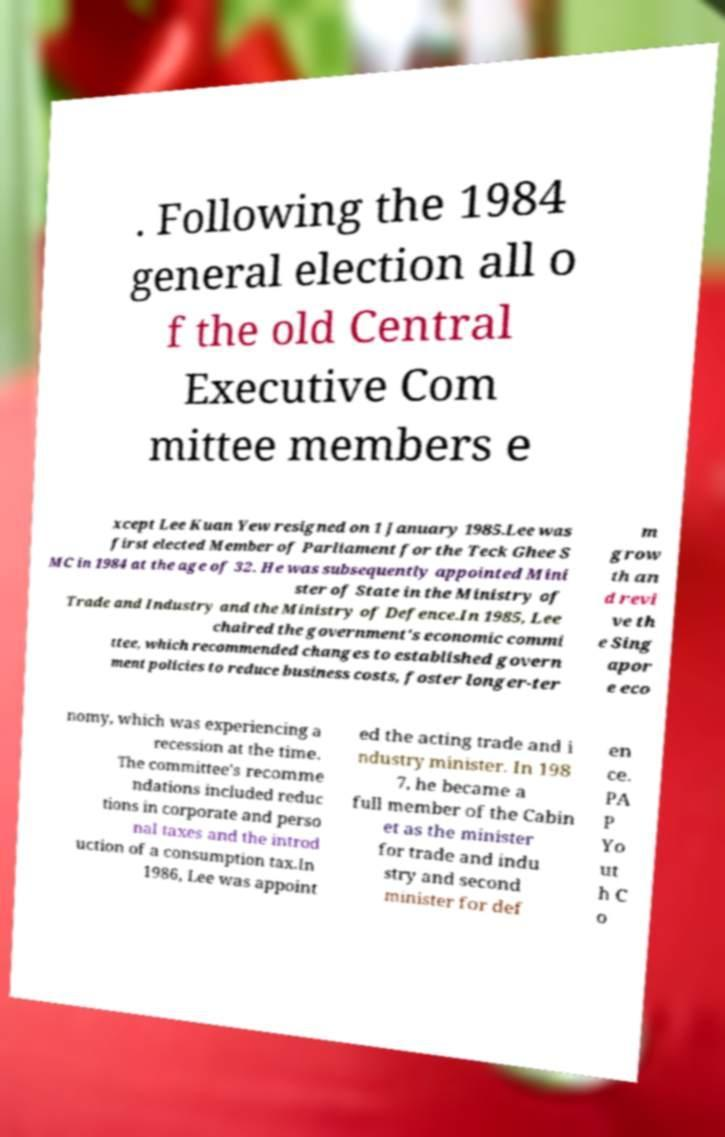There's text embedded in this image that I need extracted. Can you transcribe it verbatim? . Following the 1984 general election all o f the old Central Executive Com mittee members e xcept Lee Kuan Yew resigned on 1 January 1985.Lee was first elected Member of Parliament for the Teck Ghee S MC in 1984 at the age of 32. He was subsequently appointed Mini ster of State in the Ministry of Trade and Industry and the Ministry of Defence.In 1985, Lee chaired the government's economic commi ttee, which recommended changes to established govern ment policies to reduce business costs, foster longer-ter m grow th an d revi ve th e Sing apor e eco nomy, which was experiencing a recession at the time. The committee's recomme ndations included reduc tions in corporate and perso nal taxes and the introd uction of a consumption tax.In 1986, Lee was appoint ed the acting trade and i ndustry minister. In 198 7, he became a full member of the Cabin et as the minister for trade and indu stry and second minister for def en ce. PA P Yo ut h C o 